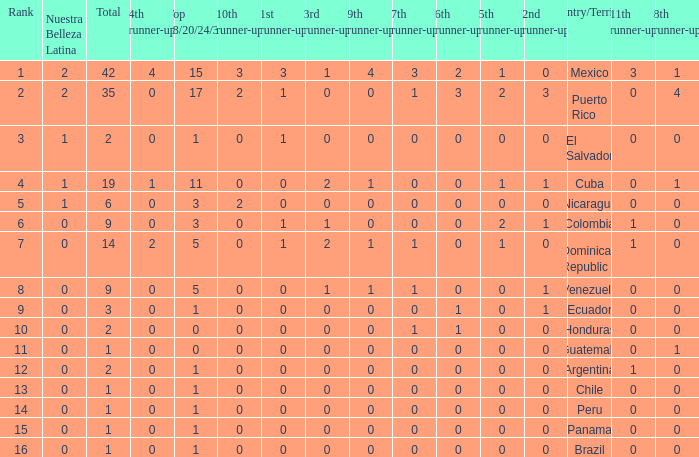What is the lowest 7th runner-up of the country with a top 18/20/24/30 greater than 5, a 1st runner-up greater than 0, and an 11th runner-up less than 0? None. 